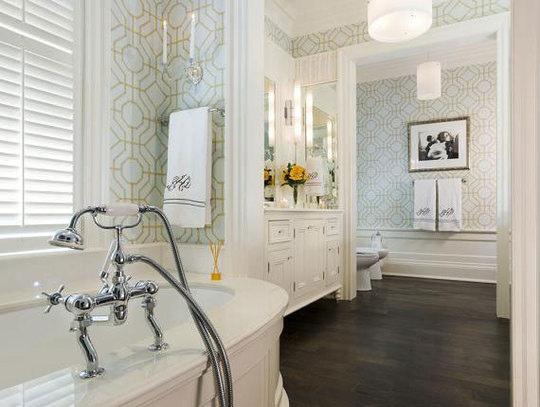Is this a fancy bathroom?
Be succinct. Yes. How many towels are there?
Quick response, please. 3. What kind of window treatments are shown?
Keep it brief. Blinds. 